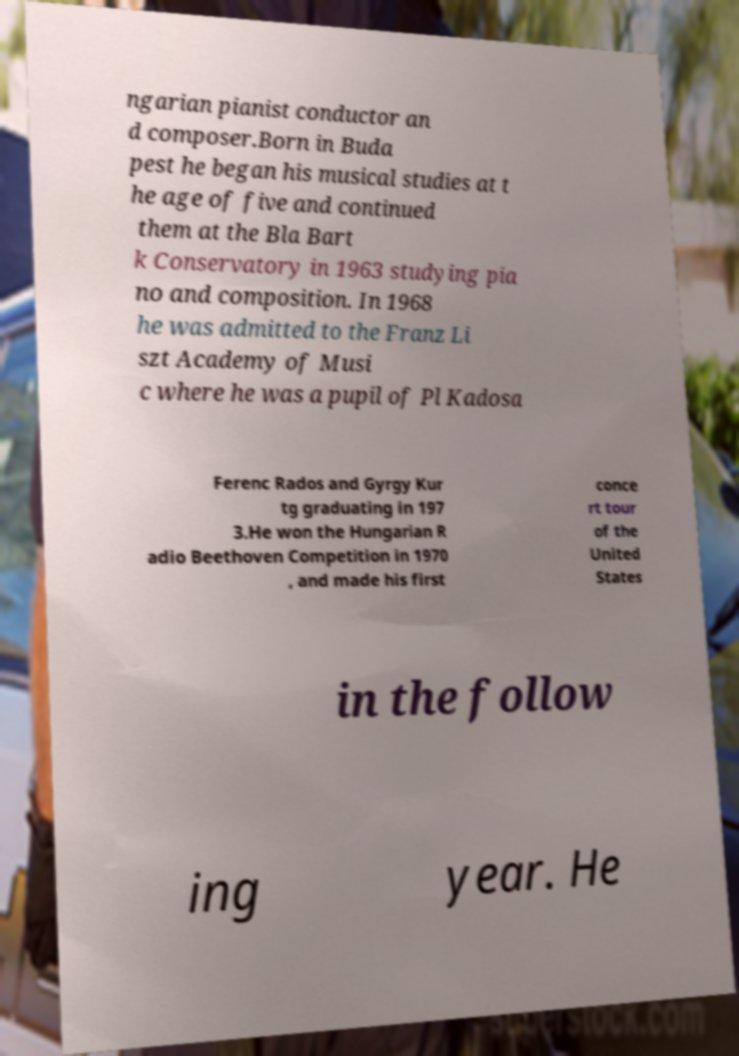What messages or text are displayed in this image? I need them in a readable, typed format. ngarian pianist conductor an d composer.Born in Buda pest he began his musical studies at t he age of five and continued them at the Bla Bart k Conservatory in 1963 studying pia no and composition. In 1968 he was admitted to the Franz Li szt Academy of Musi c where he was a pupil of Pl Kadosa Ferenc Rados and Gyrgy Kur tg graduating in 197 3.He won the Hungarian R adio Beethoven Competition in 1970 , and made his first conce rt tour of the United States in the follow ing year. He 